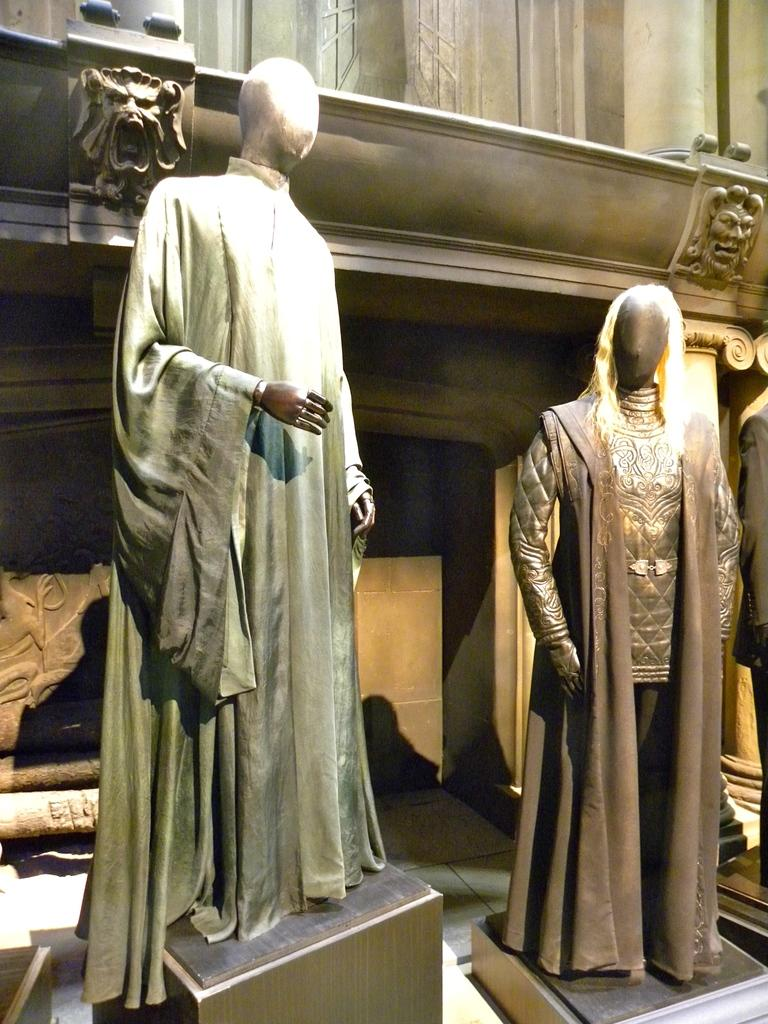What can be seen in the image that resembles a human figure? There are mannequins in the image that resemble human figures. What are the mannequins wearing? The mannequins are wearing clothes. What can be seen in the background of the image? There are two symbols in the background of the image. What type of waste can be seen in the image? There is no waste present in the image. Can you describe the wave pattern on the mannequins' clothes? There is no wave pattern mentioned on the mannequins' clothes in the image. 